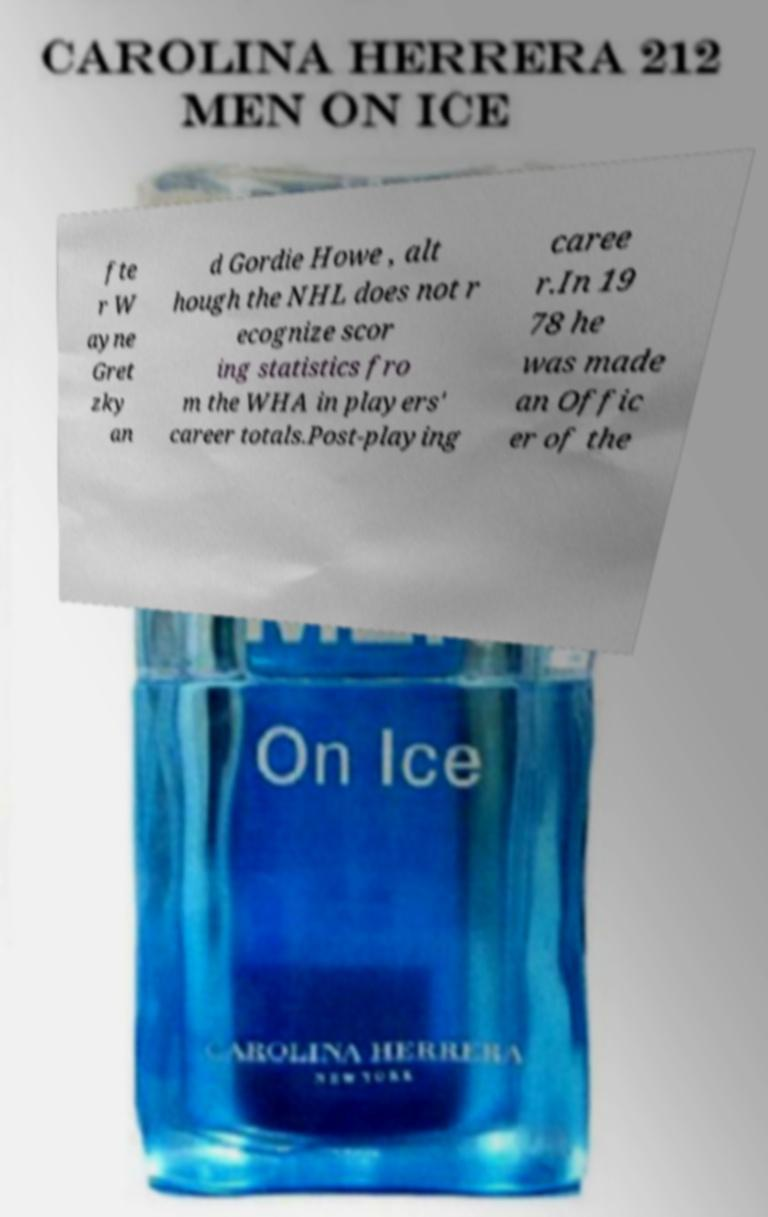Could you extract and type out the text from this image? fte r W ayne Gret zky an d Gordie Howe , alt hough the NHL does not r ecognize scor ing statistics fro m the WHA in players' career totals.Post-playing caree r.In 19 78 he was made an Offic er of the 